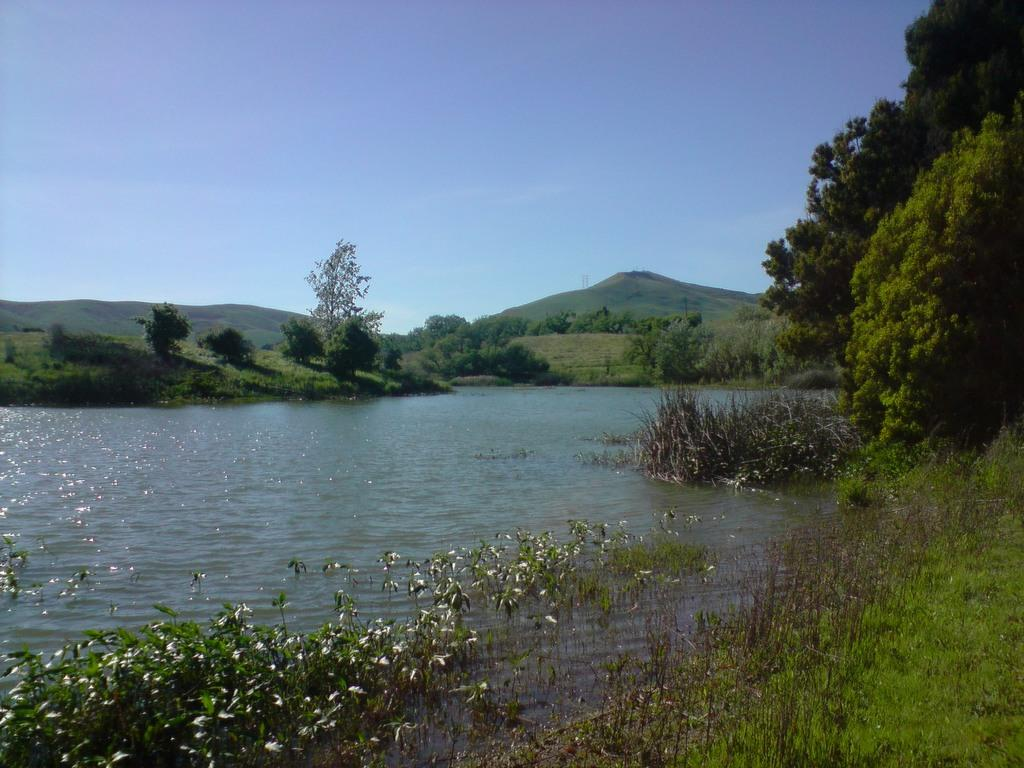What type of natural feature is present in the image? There is a river in the image. What type of vegetation can be seen around the river? There is grass, plants, and trees around the river. What other geographical feature is visible in the image? There are mountains in the image. What part of the natural environment is visible in the image? The sky is visible in the image. How many trains can be seen passing through the river in the image? There are no trains present in the image, and trains cannot pass through rivers. What type of wheel is visible on the plants around the river? There are no wheels present on the plants in the image; plants do not have wheels. 